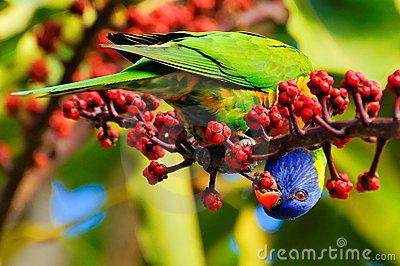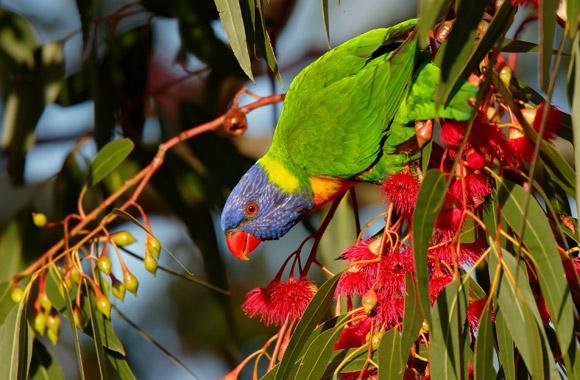The first image is the image on the left, the second image is the image on the right. Assess this claim about the two images: "An image shows exactly one parrot perched among branches of red flowers with tendril petals.". Correct or not? Answer yes or no. Yes. The first image is the image on the left, the second image is the image on the right. Examine the images to the left and right. Is the description "Two birds are facing the same direction." accurate? Answer yes or no. No. 